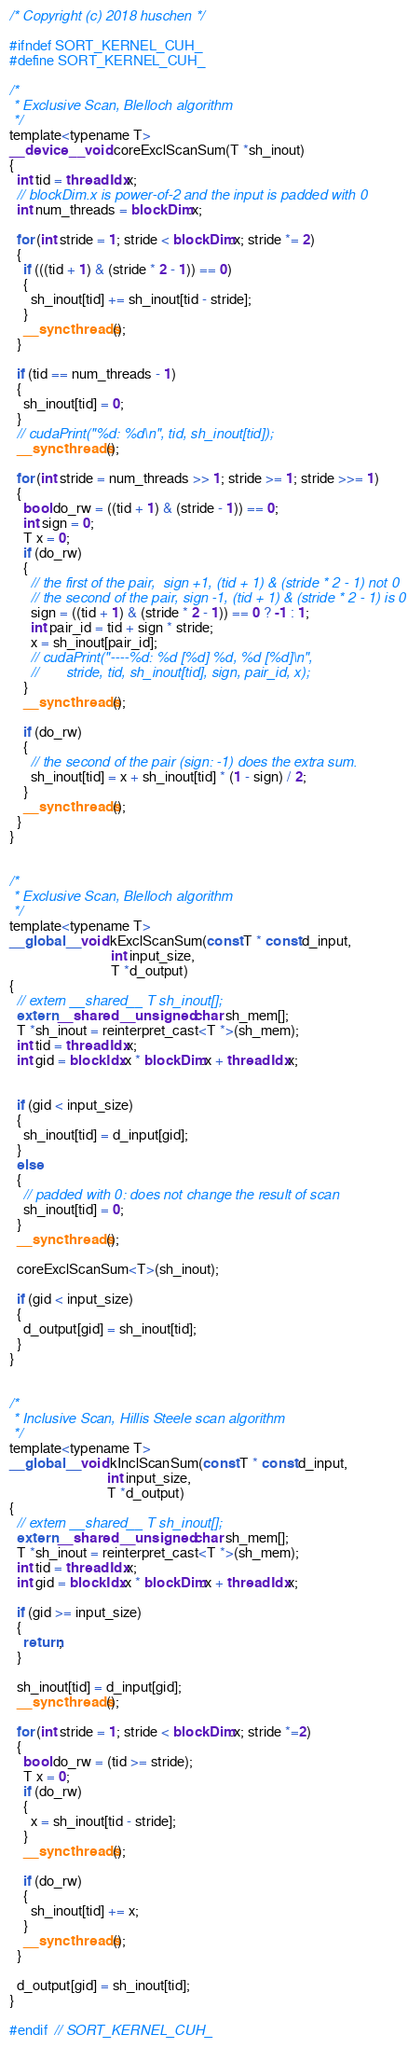<code> <loc_0><loc_0><loc_500><loc_500><_Cuda_>/* Copyright (c) 2018 huschen */

#ifndef SORT_KERNEL_CUH_
#define SORT_KERNEL_CUH_

/*
 * Exclusive Scan, Blelloch algorithm
 */
template<typename T>
__device__ void coreExclScanSum(T *sh_inout)
{
  int tid = threadIdx.x;
  // blockDim.x is power-of-2 and the input is padded with 0
  int num_threads = blockDim.x;

  for (int stride = 1; stride < blockDim.x; stride *= 2)
  {
    if (((tid + 1) & (stride * 2 - 1)) == 0)
    {
      sh_inout[tid] += sh_inout[tid - stride];
    }
    __syncthreads();
  }

  if (tid == num_threads - 1)
  {
    sh_inout[tid] = 0;
  }
  // cudaPrint("%d: %d\n", tid, sh_inout[tid]);
  __syncthreads();

  for (int stride = num_threads >> 1; stride >= 1; stride >>= 1)
  {
    bool do_rw = ((tid + 1) & (stride - 1)) == 0;
    int sign = 0;
    T x = 0;
    if (do_rw)
    {
      // the first of the pair,  sign +1, (tid + 1) & (stride * 2 - 1) not 0
      // the second of the pair, sign -1, (tid + 1) & (stride * 2 - 1) is 0
      sign = ((tid + 1) & (stride * 2 - 1)) == 0 ? -1 : 1;
      int pair_id = tid + sign * stride;
      x = sh_inout[pair_id];
      // cudaPrint("----%d: %d [%d] %d, %d [%d]\n",
      //       stride, tid, sh_inout[tid], sign, pair_id, x);
    }
    __syncthreads();

    if (do_rw)
    {
      // the second of the pair (sign: -1) does the extra sum.
      sh_inout[tid] = x + sh_inout[tid] * (1 - sign) / 2;
    }
    __syncthreads();
  }
}


/*
 * Exclusive Scan, Blelloch algorithm
 */
template<typename T>
__global__ void kExclScanSum(const T * const d_input,
                             int input_size,
                             T *d_output)
{
  // extern __shared__ T sh_inout[];
  extern __shared__ unsigned char sh_mem[];
  T *sh_inout = reinterpret_cast<T *>(sh_mem);
  int tid = threadIdx.x;
  int gid = blockIdx.x * blockDim.x + threadIdx.x;


  if (gid < input_size)
  {
    sh_inout[tid] = d_input[gid];
  }
  else
  {
    // padded with 0: does not change the result of scan
    sh_inout[tid] = 0;
  }
  __syncthreads();

  coreExclScanSum<T>(sh_inout);

  if (gid < input_size)
  {
    d_output[gid] = sh_inout[tid];
  }
}


/*
 * Inclusive Scan, Hillis Steele scan algorithm
 */
template<typename T>
__global__ void kInclScanSum(const T * const d_input,
                            int input_size,
                            T *d_output)
{
  // extern __shared__ T sh_inout[];
  extern __shared__ unsigned char sh_mem[];
  T *sh_inout = reinterpret_cast<T *>(sh_mem);
  int tid = threadIdx.x;
  int gid = blockIdx.x * blockDim.x + threadIdx.x;

  if (gid >= input_size)
  {
    return;
  }

  sh_inout[tid] = d_input[gid];
  __syncthreads();

  for (int stride = 1; stride < blockDim.x; stride *=2)
  {
    bool do_rw = (tid >= stride);
    T x = 0;
    if (do_rw)
    {
      x = sh_inout[tid - stride];
    }
    __syncthreads();

    if (do_rw)
    {
      sh_inout[tid] += x;
    }
    __syncthreads();
  }

  d_output[gid] = sh_inout[tid];
}

#endif  // SORT_KERNEL_CUH_
</code> 